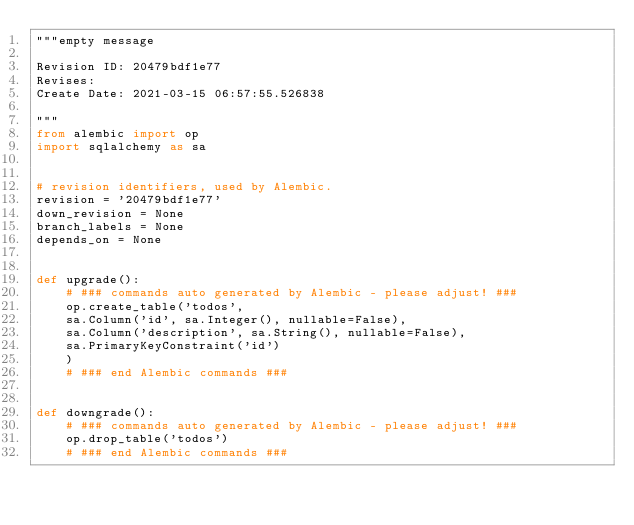Convert code to text. <code><loc_0><loc_0><loc_500><loc_500><_Python_>"""empty message

Revision ID: 20479bdf1e77
Revises: 
Create Date: 2021-03-15 06:57:55.526838

"""
from alembic import op
import sqlalchemy as sa


# revision identifiers, used by Alembic.
revision = '20479bdf1e77'
down_revision = None
branch_labels = None
depends_on = None


def upgrade():
    # ### commands auto generated by Alembic - please adjust! ###
    op.create_table('todos',
    sa.Column('id', sa.Integer(), nullable=False),
    sa.Column('description', sa.String(), nullable=False),
    sa.PrimaryKeyConstraint('id')
    )
    # ### end Alembic commands ###


def downgrade():
    # ### commands auto generated by Alembic - please adjust! ###
    op.drop_table('todos')
    # ### end Alembic commands ###
</code> 